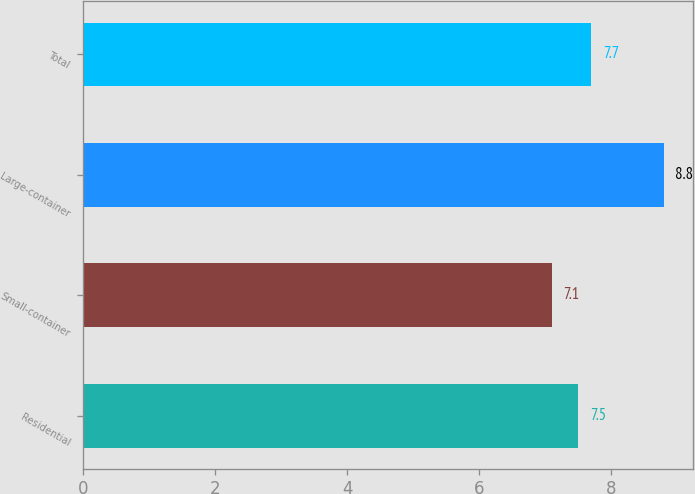Convert chart. <chart><loc_0><loc_0><loc_500><loc_500><bar_chart><fcel>Residential<fcel>Small-container<fcel>Large-container<fcel>Total<nl><fcel>7.5<fcel>7.1<fcel>8.8<fcel>7.7<nl></chart> 